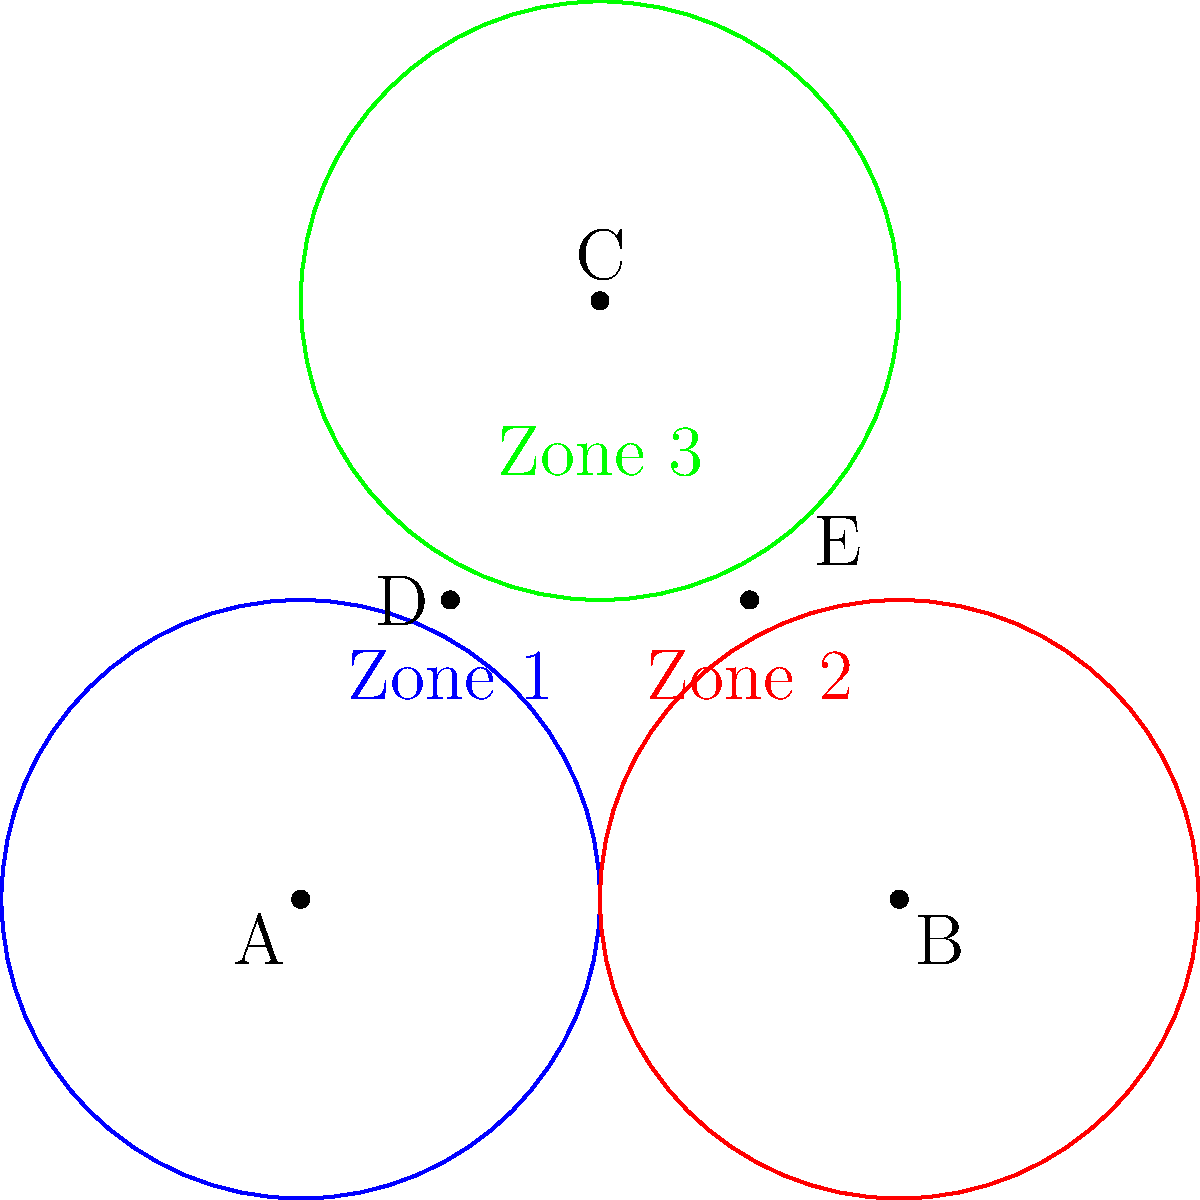In the diagram above, three speakers are positioned at points A, B, and C, each with a circular sound coverage radius of 2 units. Points D and E represent audience locations. How many different sound coverage zones does point E fall within? To determine the number of sound coverage zones that point E falls within, we need to check its position relative to each speaker's coverage area. Let's go through this step-by-step:

1. Speaker at point A:
   - The distance between A(0,0) and E(3,2) is $\sqrt{3^2 + 2^2} = \sqrt{13} \approx 3.61$ units.
   - Since this is greater than 2, point E is outside speaker A's coverage.

2. Speaker at point B:
   - The distance between B(4,0) and E(3,2) is $\sqrt{1^2 + 2^2} = \sqrt{5} \approx 2.24$ units.
   - Since this is less than 2, point E is inside speaker B's coverage.

3. Speaker at point C:
   - The distance between C(2,4) and E(3,2) is $\sqrt{1^2 + 2^2} = \sqrt{5} \approx 2.24$ units.
   - Since this is less than 2, point E is inside speaker C's coverage.

Therefore, point E falls within the coverage zones of speakers B and C, which means it is in 2 different sound coverage zones.
Answer: 2 